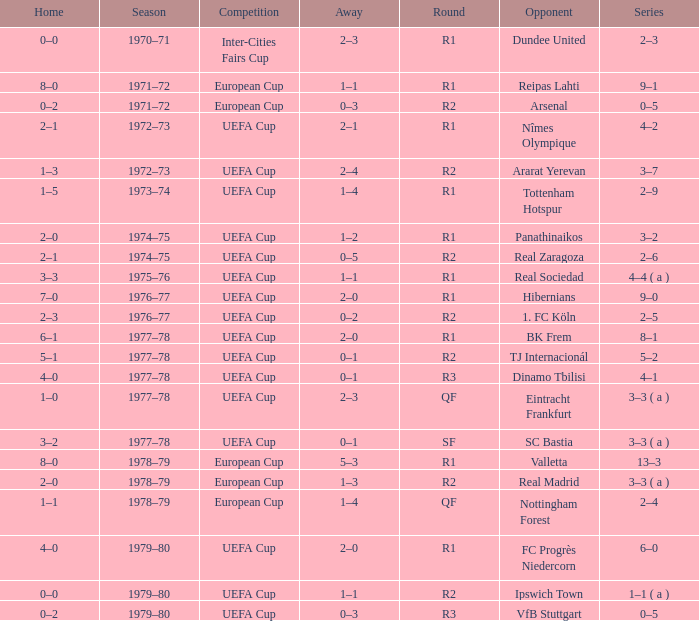Which Home has a Competition of european cup, and a Round of qf? 1–1. 